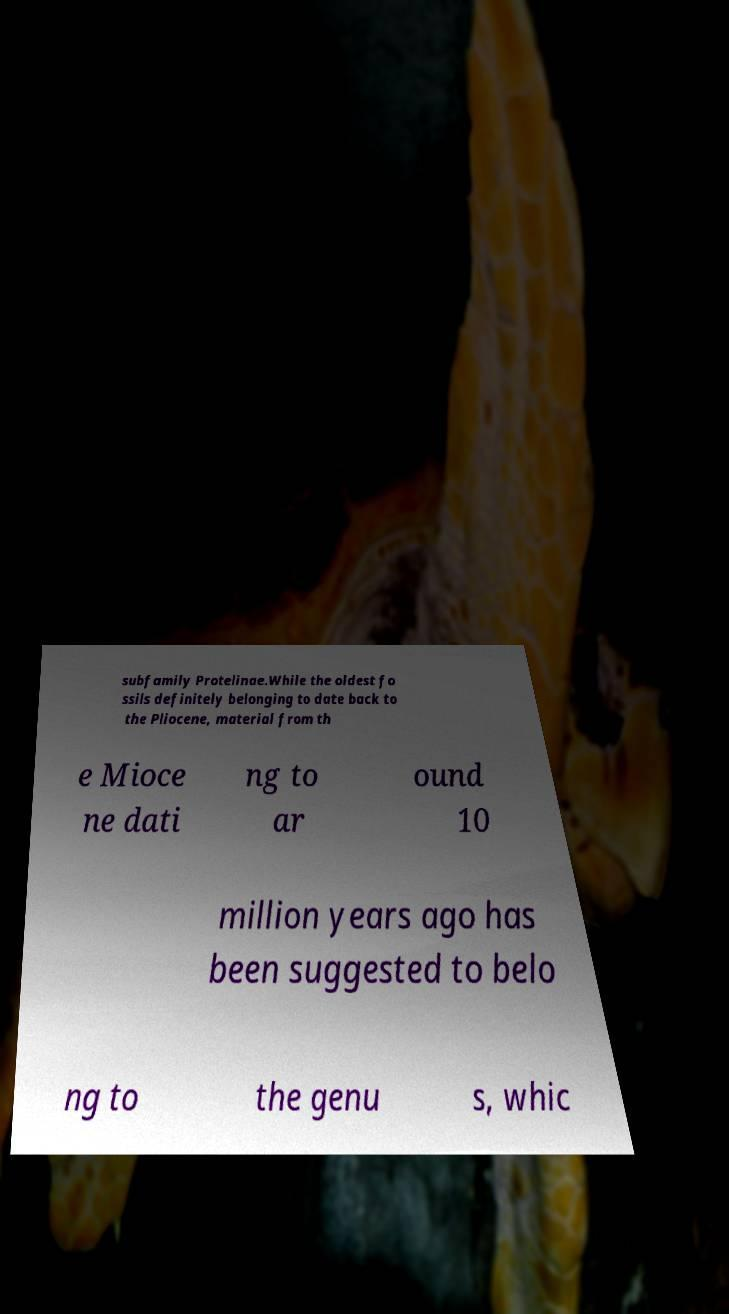What messages or text are displayed in this image? I need them in a readable, typed format. subfamily Protelinae.While the oldest fo ssils definitely belonging to date back to the Pliocene, material from th e Mioce ne dati ng to ar ound 10 million years ago has been suggested to belo ng to the genu s, whic 